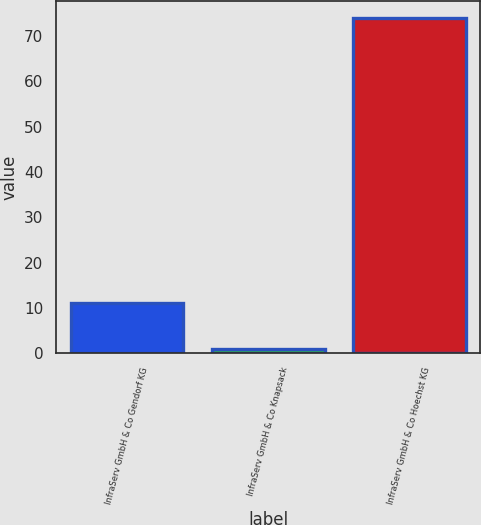<chart> <loc_0><loc_0><loc_500><loc_500><bar_chart><fcel>InfraServ GmbH & Co Gendorf KG<fcel>InfraServ GmbH & Co Knapsack<fcel>InfraServ GmbH & Co Hoechst KG<nl><fcel>11<fcel>1<fcel>74<nl></chart> 